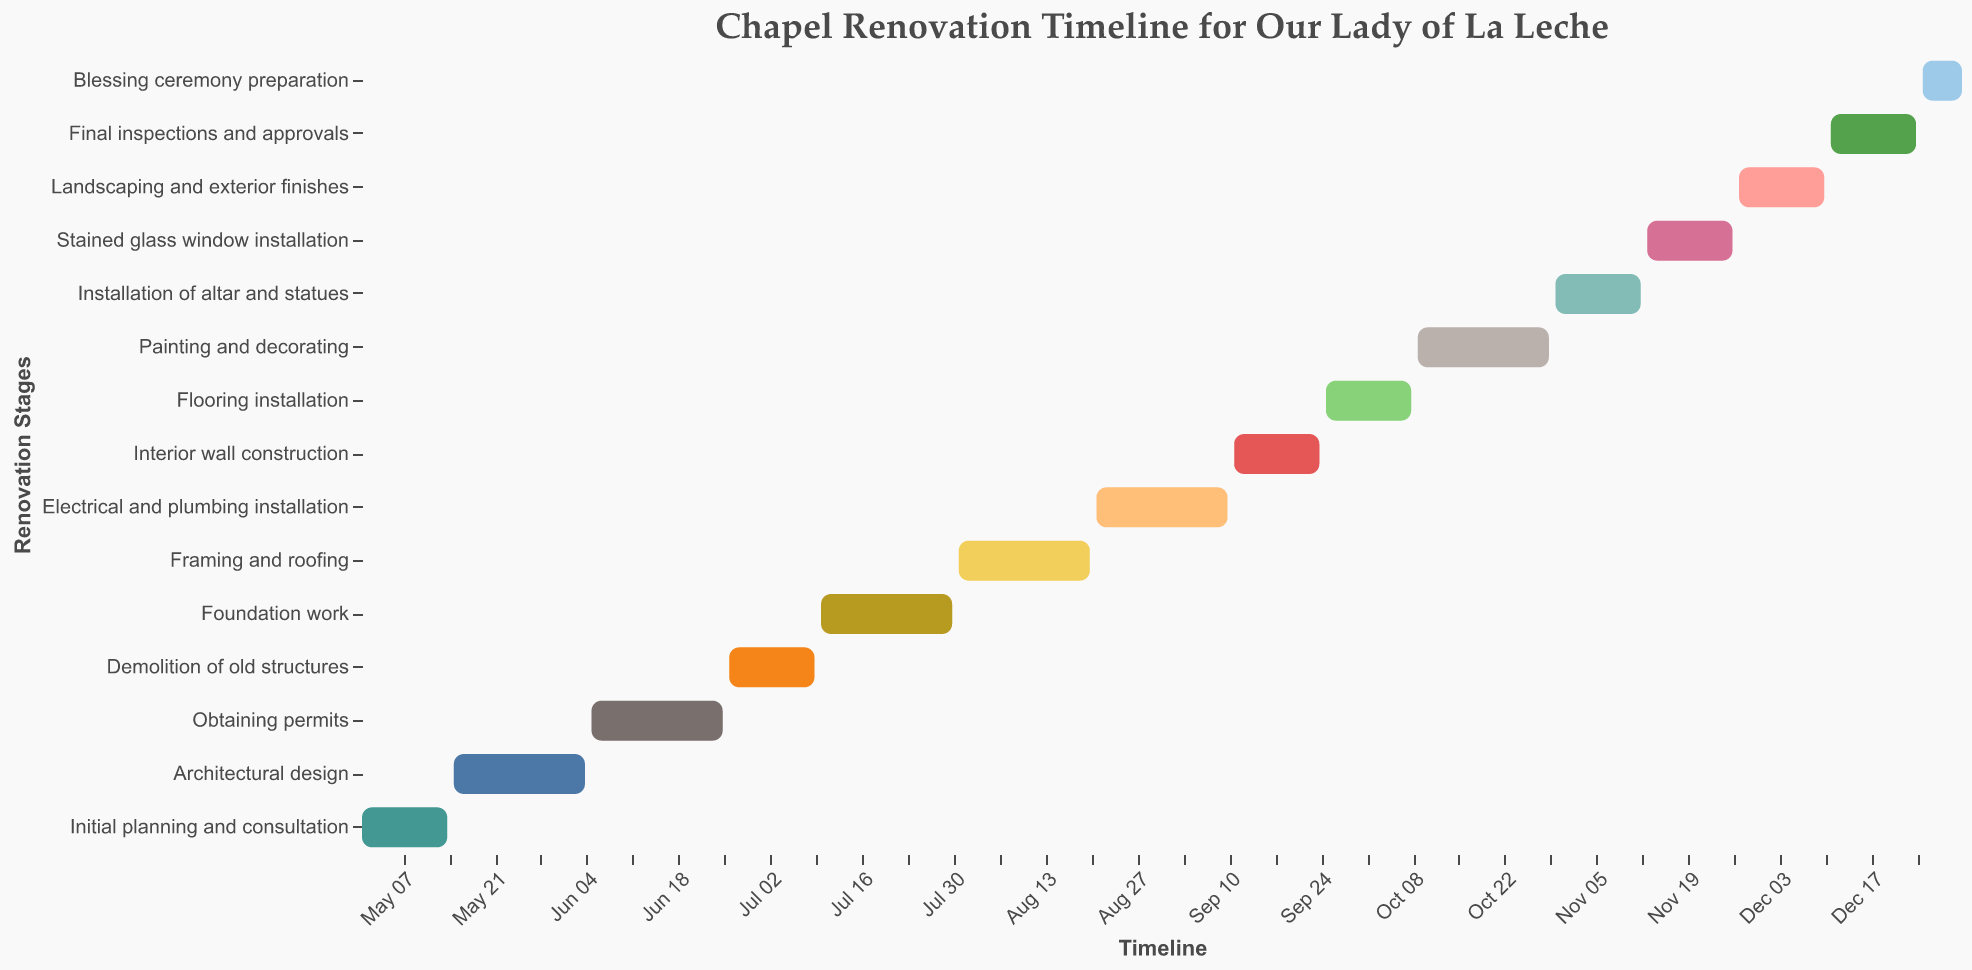What is the duration of the "Foundation work" stage? Locate the "Foundation work" task on the y-axis and check its duration in the tooltip.
Answer: 21 days Which stage starts immediately after "Architectural design"? Identify the end date of "Architectural design" and see which task begins on the following date.
Answer: Obtaining permits What is the total duration of "Demolition of old structures" and "Foundation work"? Summing up the durations from the tooltip for "Demolition of old structures" and "Foundation work," we get 14 + 21.
Answer: 35 days When does the "Painting and decorating" stage start and end? Locate the "Painting and decorating" task on the y-axis and check its start and end dates in the tooltip.
Answer: October 9, 2023, to October 29, 2023 Which stage has the shortest duration? Compare the durations of all tasks using either the bars' lengths or tooltip information to find the shortest one.
Answer: Blessing ceremony preparation How long does it take from the start of the "Initial planning and consultation" to the end of the "Blessing ceremony preparation"? Find the start date of "Initial planning and consultation" (May 1, 2023) and the end date of "Blessing ceremony preparation" (December 31, 2023), then compute the total days between these dates.
Answer: 245 days Which stages overlap with "Electrical and plumbing installation"? Determine the time range of "Electrical and plumbing installation" from the chart, then identify other tasks with overlapping dates.
Answer: Interior wall construction and Flooring installation How many stages are involved in the renovation process? Count the number of distinct tasks listed on the y-axis.
Answer: 15 stages Which stage immediately follows the "Final inspections and approvals"? Identify the end date of "Final inspections and approvals" and see which task starts on the subsequent date.
Answer: Blessing ceremony preparation 